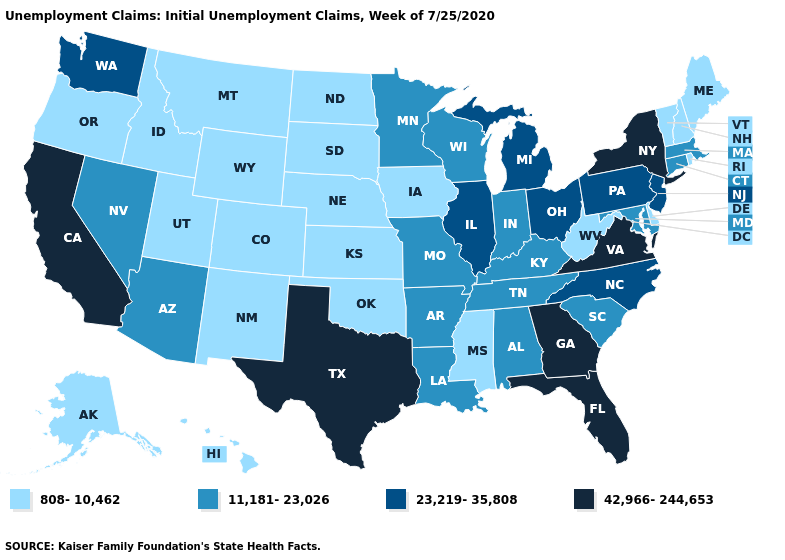Name the states that have a value in the range 42,966-244,653?
Keep it brief. California, Florida, Georgia, New York, Texas, Virginia. Does Missouri have the same value as California?
Write a very short answer. No. Does Arkansas have the same value as North Carolina?
Give a very brief answer. No. Name the states that have a value in the range 23,219-35,808?
Concise answer only. Illinois, Michigan, New Jersey, North Carolina, Ohio, Pennsylvania, Washington. Does Kansas have the highest value in the MidWest?
Concise answer only. No. Does Massachusetts have the highest value in the USA?
Concise answer only. No. Name the states that have a value in the range 42,966-244,653?
Short answer required. California, Florida, Georgia, New York, Texas, Virginia. Name the states that have a value in the range 11,181-23,026?
Concise answer only. Alabama, Arizona, Arkansas, Connecticut, Indiana, Kentucky, Louisiana, Maryland, Massachusetts, Minnesota, Missouri, Nevada, South Carolina, Tennessee, Wisconsin. Does the first symbol in the legend represent the smallest category?
Give a very brief answer. Yes. What is the value of Utah?
Give a very brief answer. 808-10,462. Which states have the highest value in the USA?
Give a very brief answer. California, Florida, Georgia, New York, Texas, Virginia. Does Mississippi have the highest value in the USA?
Quick response, please. No. What is the value of Pennsylvania?
Short answer required. 23,219-35,808. What is the value of New Mexico?
Quick response, please. 808-10,462. What is the value of Maine?
Short answer required. 808-10,462. 